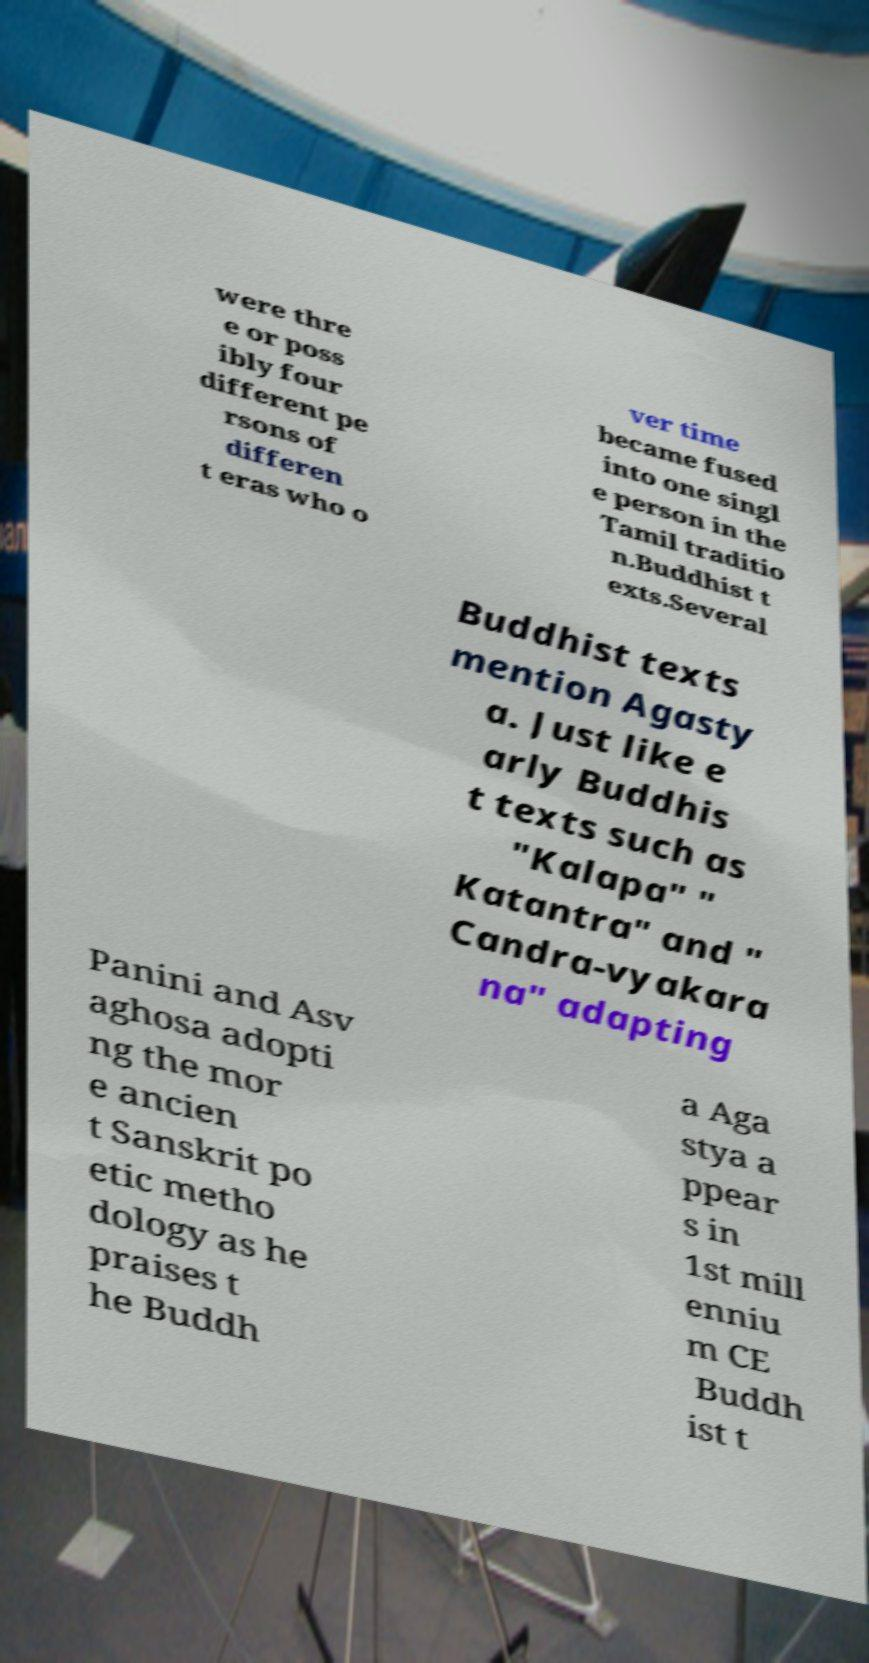What messages or text are displayed in this image? I need them in a readable, typed format. were thre e or poss ibly four different pe rsons of differen t eras who o ver time became fused into one singl e person in the Tamil traditio n.Buddhist t exts.Several Buddhist texts mention Agasty a. Just like e arly Buddhis t texts such as "Kalapa" " Katantra" and " Candra-vyakara na" adapting Panini and Asv aghosa adopti ng the mor e ancien t Sanskrit po etic metho dology as he praises t he Buddh a Aga stya a ppear s in 1st mill enniu m CE Buddh ist t 